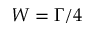Convert formula to latex. <formula><loc_0><loc_0><loc_500><loc_500>W = \Gamma / 4</formula> 